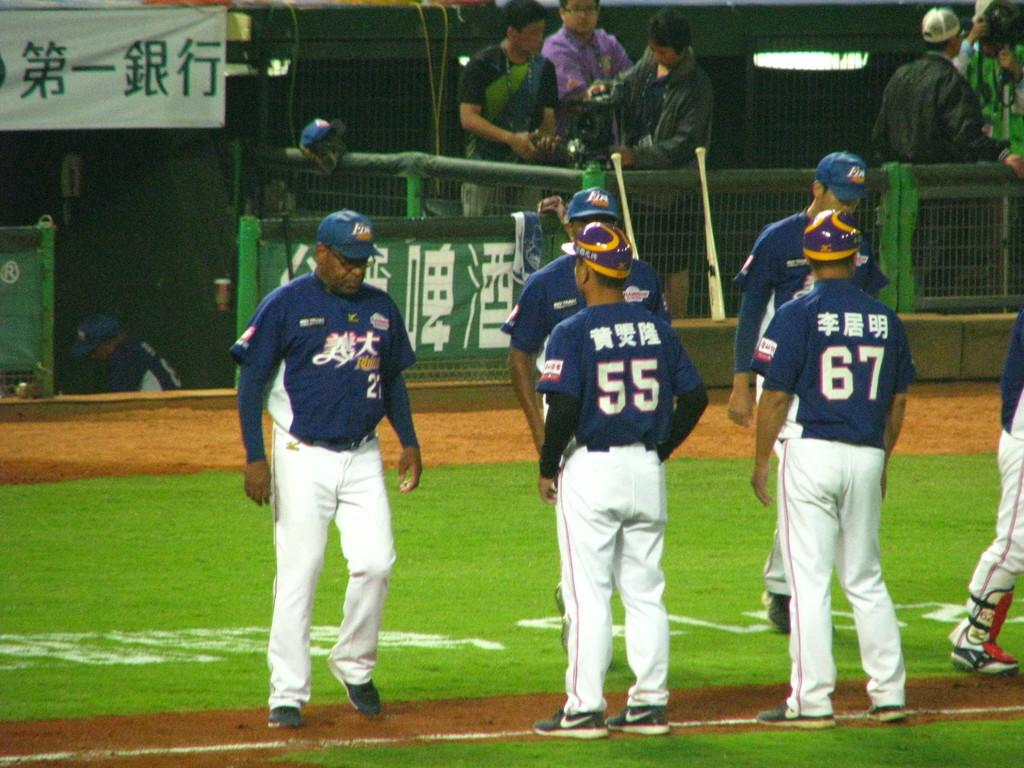Provide a one-sentence caption for the provided image. A group of Japanese baseball players stand on the field, the numbers 55 and 67 are visible on their backs. 